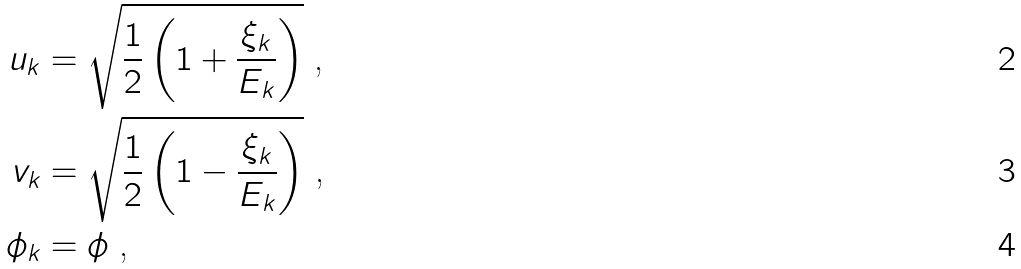<formula> <loc_0><loc_0><loc_500><loc_500>u _ { k } & = \sqrt { \frac { 1 } { 2 } \left ( 1 + \frac { \xi _ { k } } { E _ { k } } \right ) } \text { ,} \\ v _ { k } & = \sqrt { \frac { 1 } { 2 } \left ( 1 - \frac { \xi _ { k } } { E _ { k } } \right ) } \text { ,} \\ \phi _ { k } & = \phi \text { ,}</formula> 